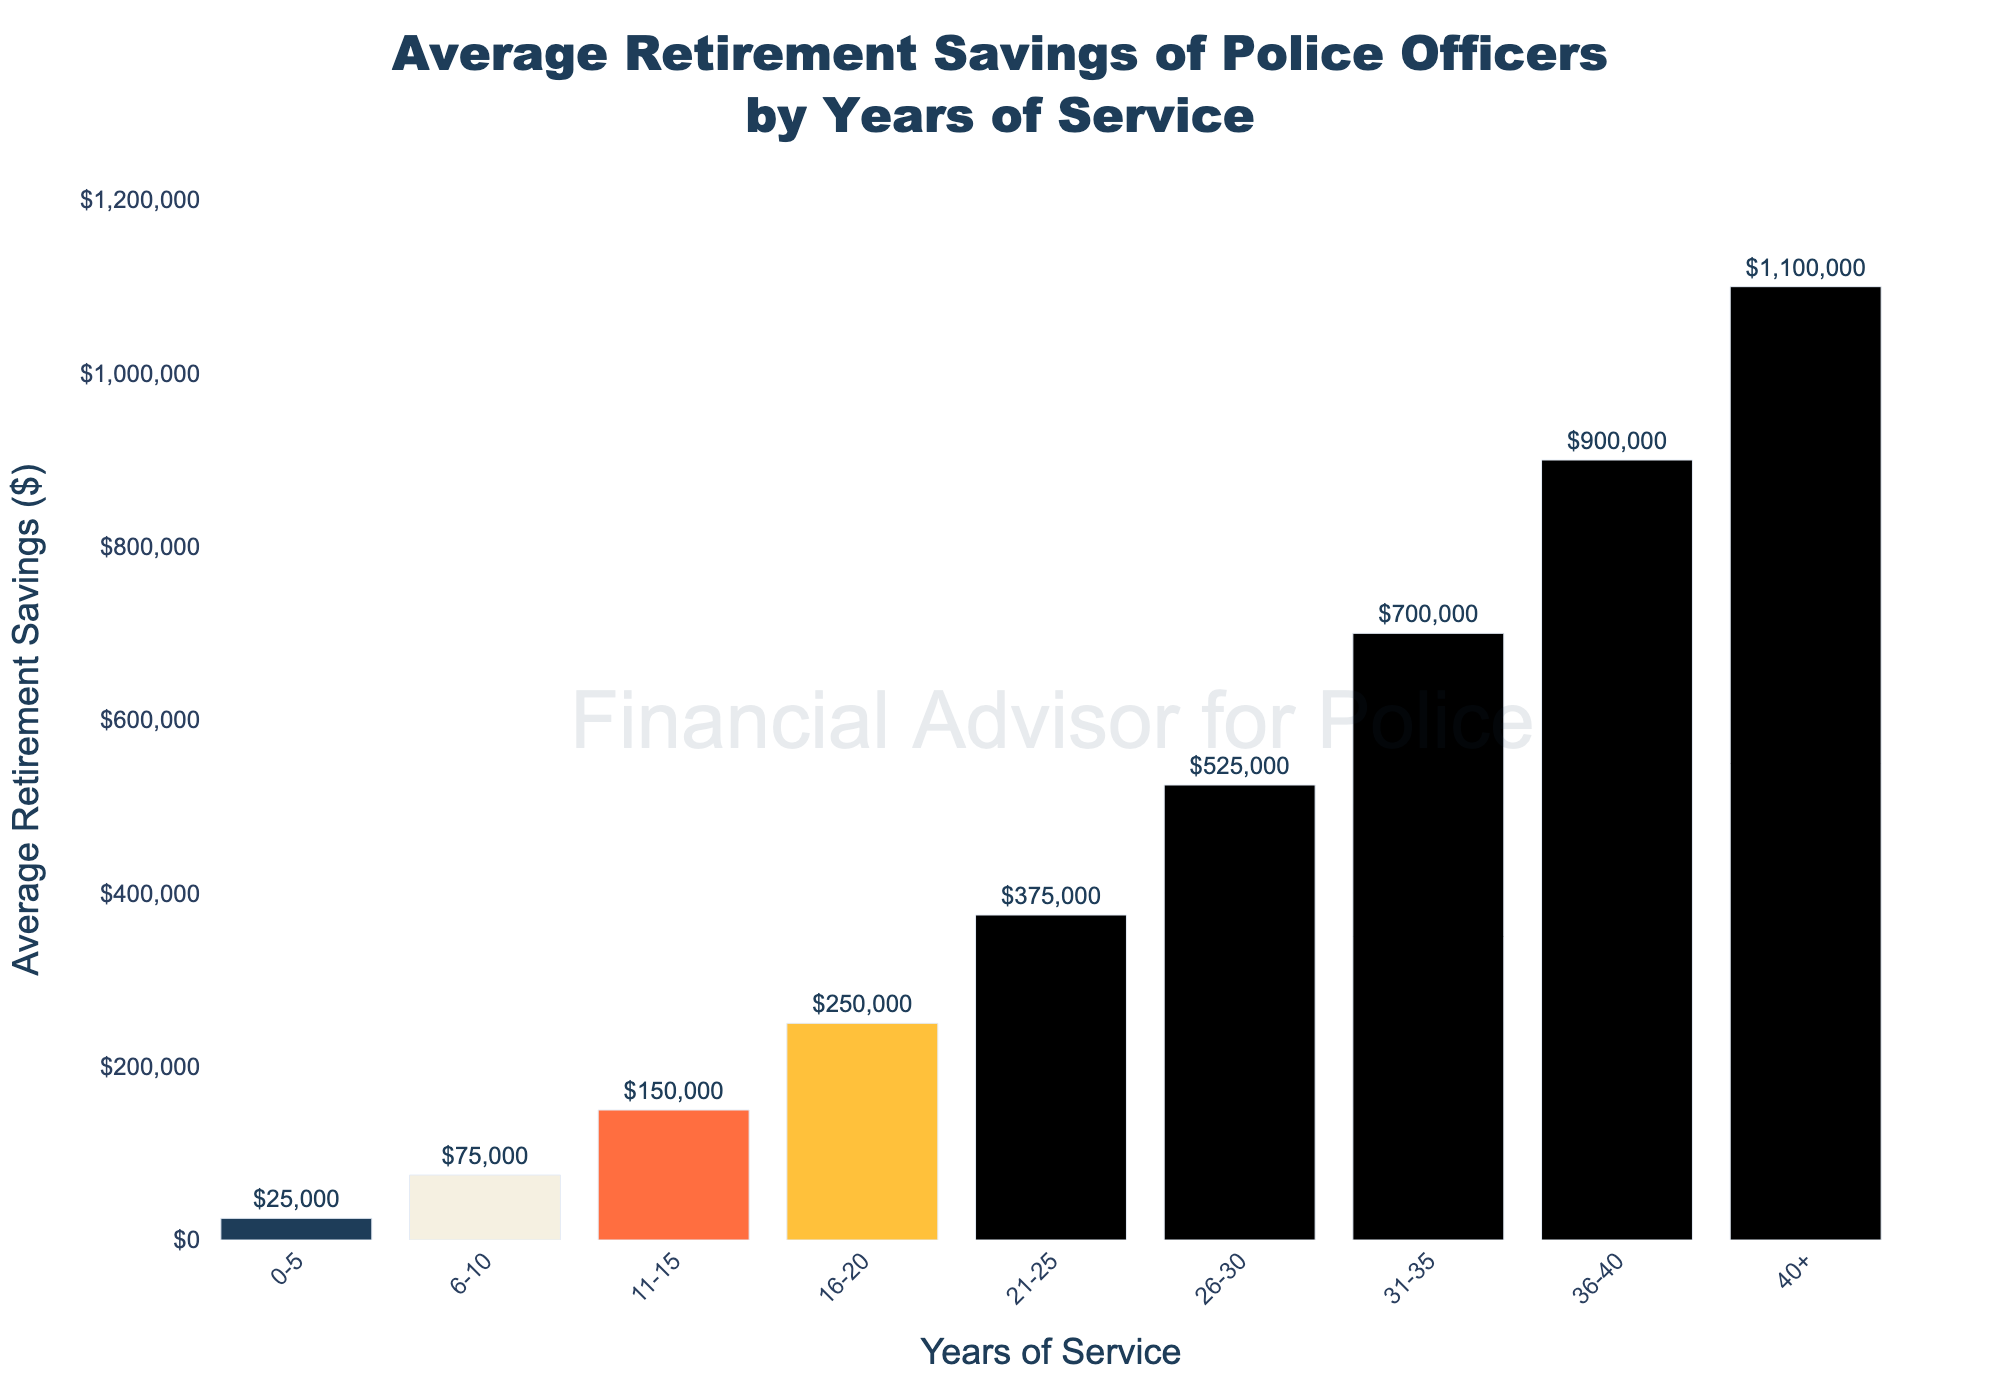How much more are average retirement savings for officers with 31-35 years of service compared to those with 6-10 years of service? Officers with 31-35 years of service have an average retirement savings of $700,000, while those with 6-10 years of service have $75,000 in savings. The difference is calculated as $700,000 - $75,000 = $625,000.
Answer: $625,000 Between which two consecutive years of service is the largest increase in average retirement savings? By visually comparing the heights of the bars, the largest increase in savings appears between 36-40 years of service ($900,000) and 40+ years of service ($1,100,000). The increase is $1,100,000 - $900,000 = $200,000.
Answer: Between 36-40 and 40+ years What is the total average retirement savings for officers with 21-25 years, 26-30 years, and 31-35 years of service combined? Add the values for the three categories: $375,000 (21-25 years) + $525,000 (26-30 years) + $700,000 (31-35 years) = $1,600,000.
Answer: $1,600,000 Which group has the smallest average retirement savings, and what is the amount? The group with the smallest savings is 0-5 years of service with $25,000.
Answer: 0-5 years, $25,000 How does the average retirement savings for officers with 16-20 years of service compare to those with 11-15 years of service? Officers with 16-20 years of service have an average retirement savings of $250,000, while those with 11-15 years of service have $150,000. The difference is $250,000 - $150,000 = $100,000 more.
Answer: $100,000 more Which bar is the tallest on the chart, and what is the average retirement savings for that group? The tallest bar on the chart represents the 40+ years of service group, with an average retirement savings of $1,100,000.
Answer: 40+ years, $1,100,000 What is the average retirement savings of police officers at midway through their career (around 20 years of service)? The bar corresponding to 16-20 years of service shows average retirement savings at $250,000.
Answer: $250,000 